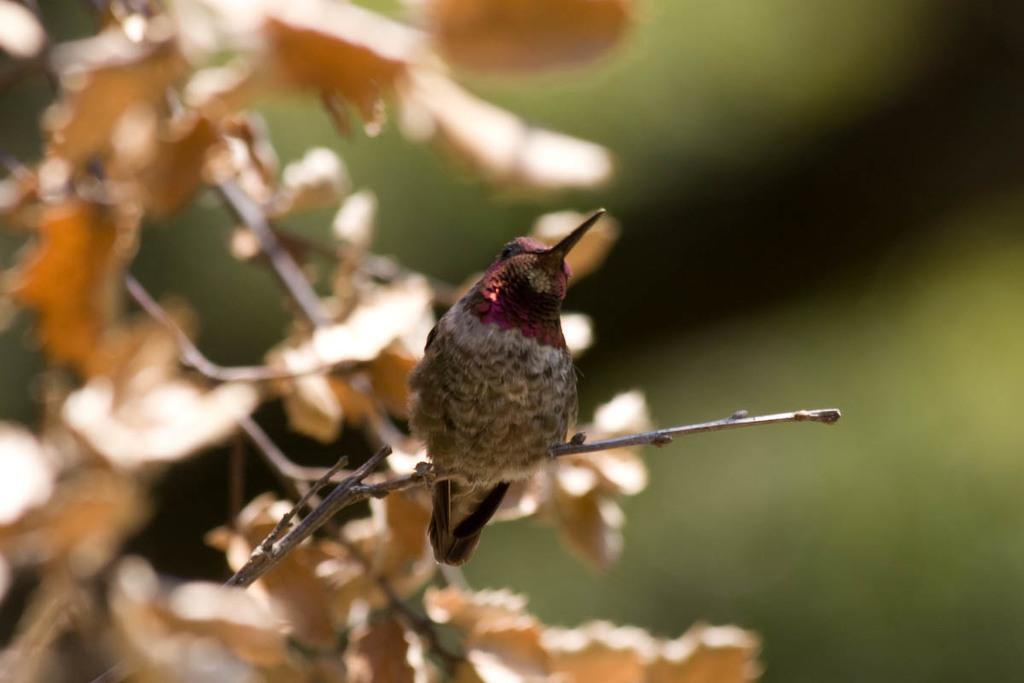What type of animal can be seen in the image? There is a bird in the image. Where is the bird located? The bird is standing on a branch of a tree. Can you describe the background of the image? The background of the image is blurred. What type of crime is being committed in the image? There is no crime being committed in the image; it features a bird standing on a branch of a tree. What type of coat is the bird wearing in the image? Birds do not wear coats, and there is no coat present in the image. 